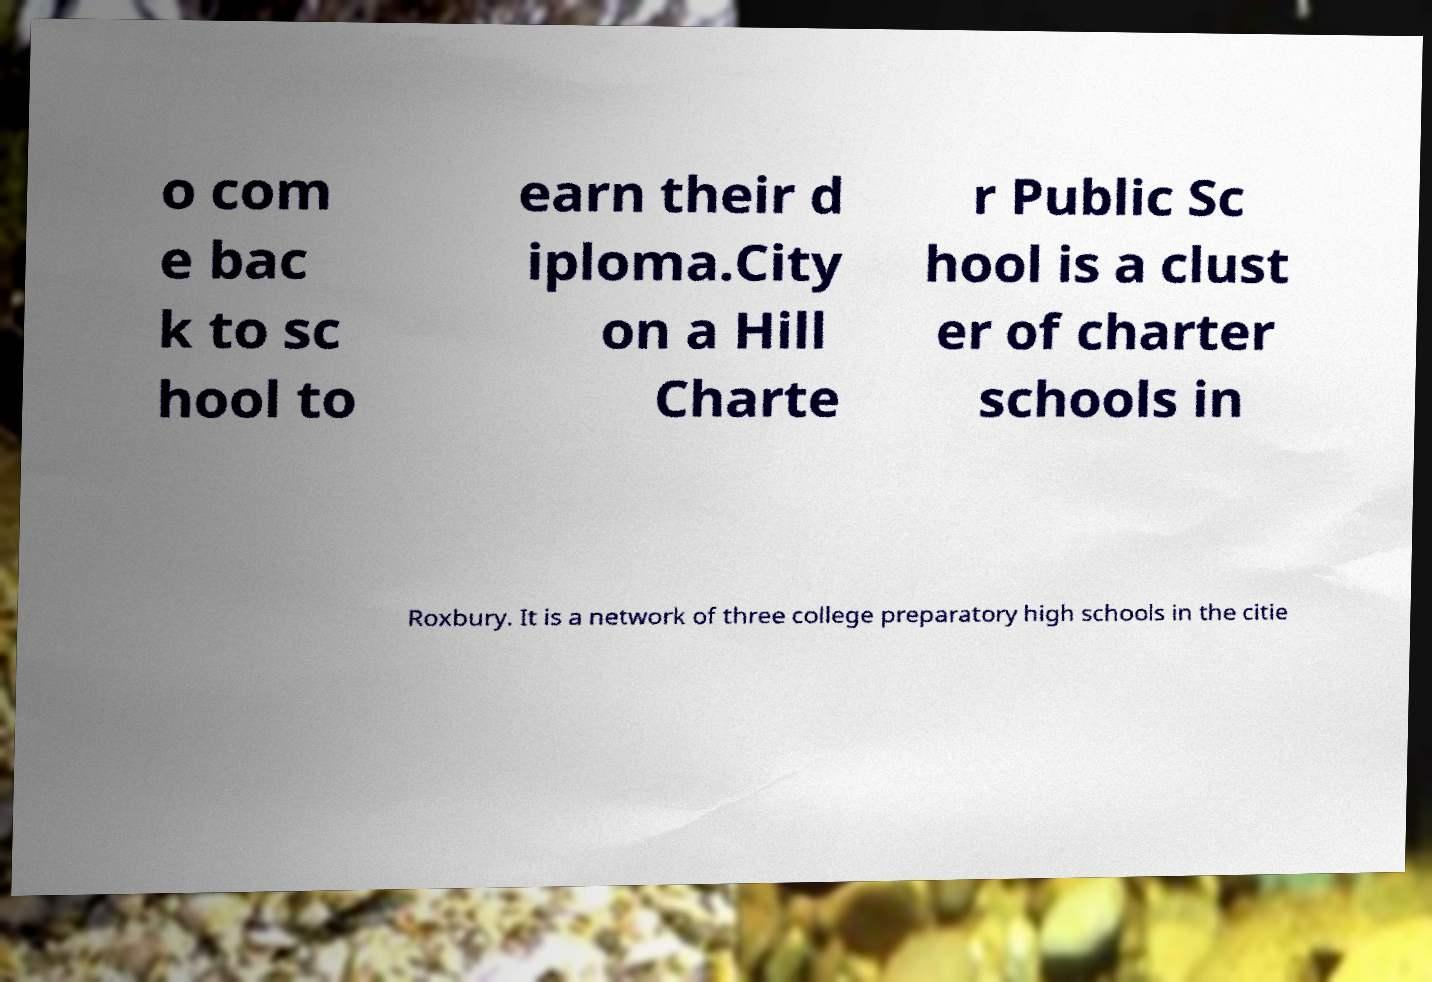I need the written content from this picture converted into text. Can you do that? o com e bac k to sc hool to earn their d iploma.City on a Hill Charte r Public Sc hool is a clust er of charter schools in Roxbury. It is a network of three college preparatory high schools in the citie 